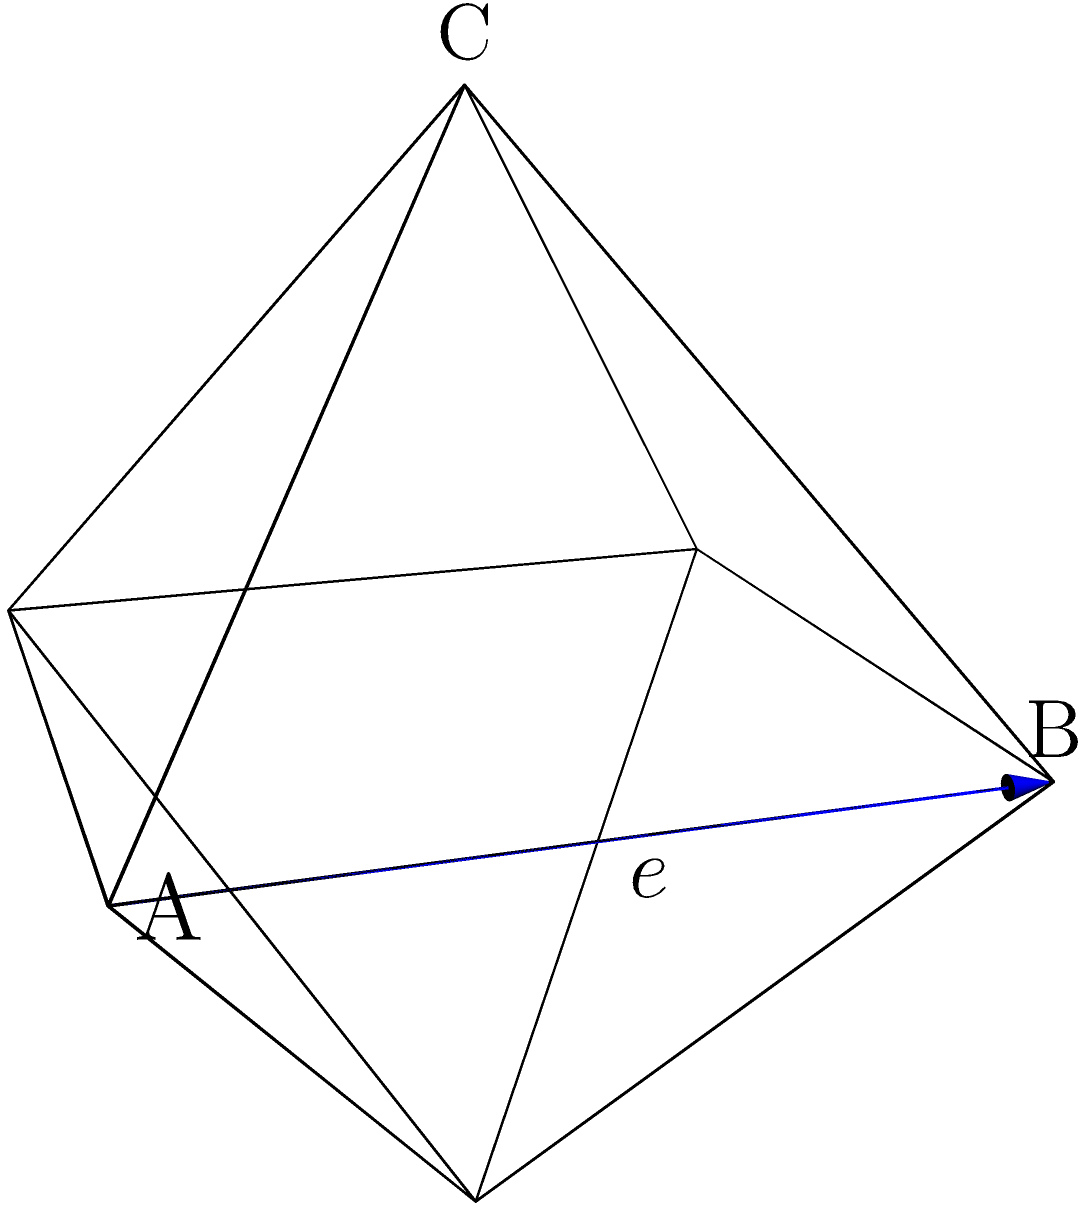In the context of emotional healing, consider an octahedron representing the multifaceted nature of forgiveness. If the edge length of this regular octahedron is $e$ units, calculate its surface area. How might this calculation process reflect the steps in addressing complex emotional issues? Let's approach this step-by-step, drawing parallels to the process of emotional healing:

1) Identify the shape: Just as we recognize the emotional challenge, we identify the shape as a regular octahedron.

2) Recall the formula: Like recalling coping strategies, we remember that the surface area of a regular octahedron is given by $SA = 2\sqrt{3}e^2$, where $e$ is the edge length.

3) Understand the components: The formula uses $\sqrt{3}$, which represents the inherent complexity of the shape, much like the complexity of emotions.

4) Calculate the area of one face: Each face is an equilateral triangle with side length $e$. The area of one face is:

   $A_{face} = \frac{\sqrt{3}}{4}e^2$

   This represents addressing one aspect of the emotional issue.

5) Count the faces: An octahedron has 8 faces, symbolizing the multiple facets of forgiveness and healing.

6) Combine the results: Multiply the area of one face by 8:

   $SA = 8 \cdot \frac{\sqrt{3}}{4}e^2 = 2\sqrt{3}e^2$

   This final step represents integrating all aspects of the healing process.

7) Simplify: The result $2\sqrt{3}e^2$ is already in its simplest form, representing the clarity achieved through the healing process.

This calculation process mirrors the steps in addressing complex emotional issues: identifying the problem, recalling strategies, understanding complexities, addressing individual aspects, recognizing multiple facets, integrating insights, and achieving clarity.
Answer: $2\sqrt{3}e^2$ 